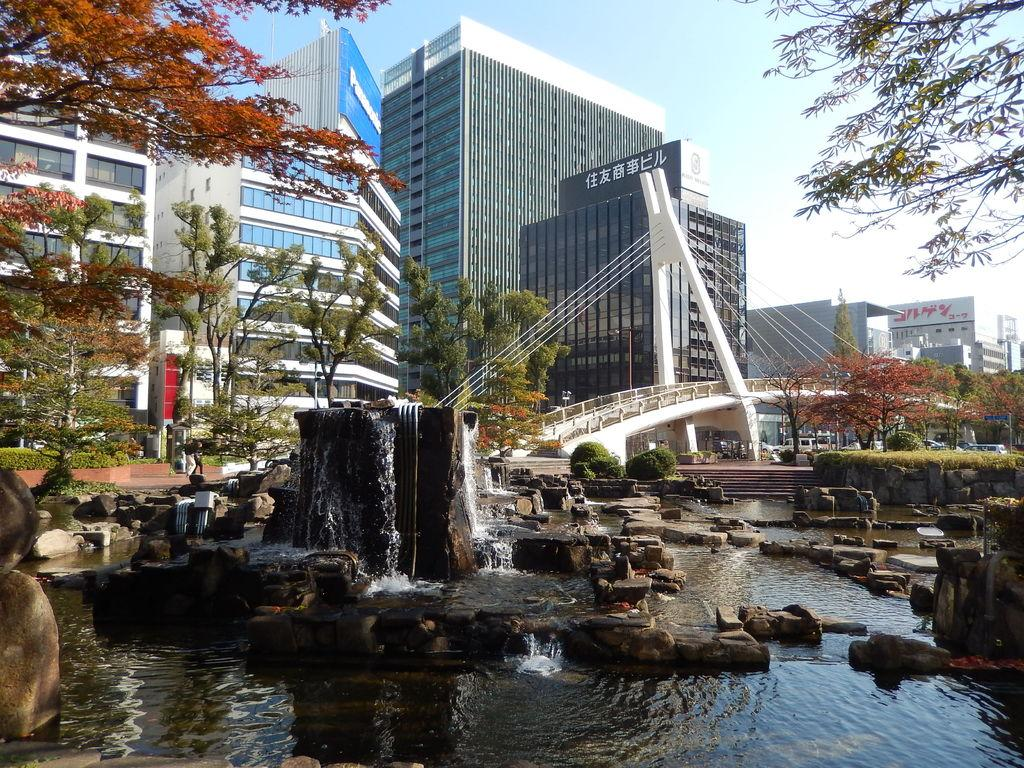What type of structures can be seen in the image? There are many buildings in the image. What type of man-made structure connects two areas in the image? There is a bridge in the image. What type of natural elements can be seen in the image? There are trees, rocks, and water visible in the image. What type of small vegetation is present in the image? There are small plants in the image. What part of the natural environment is visible in the image? The sky is visible in the image. Can you tell me how many people are smiling in the image? There is no indication of people or smiles in the image; it primarily features buildings, a bridge, trees, rocks, water, small plants, and the sky. 